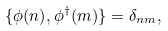<formula> <loc_0><loc_0><loc_500><loc_500>\{ \phi ( n ) , \phi ^ { \dagger } ( m ) \} = \delta _ { n m } ,</formula> 